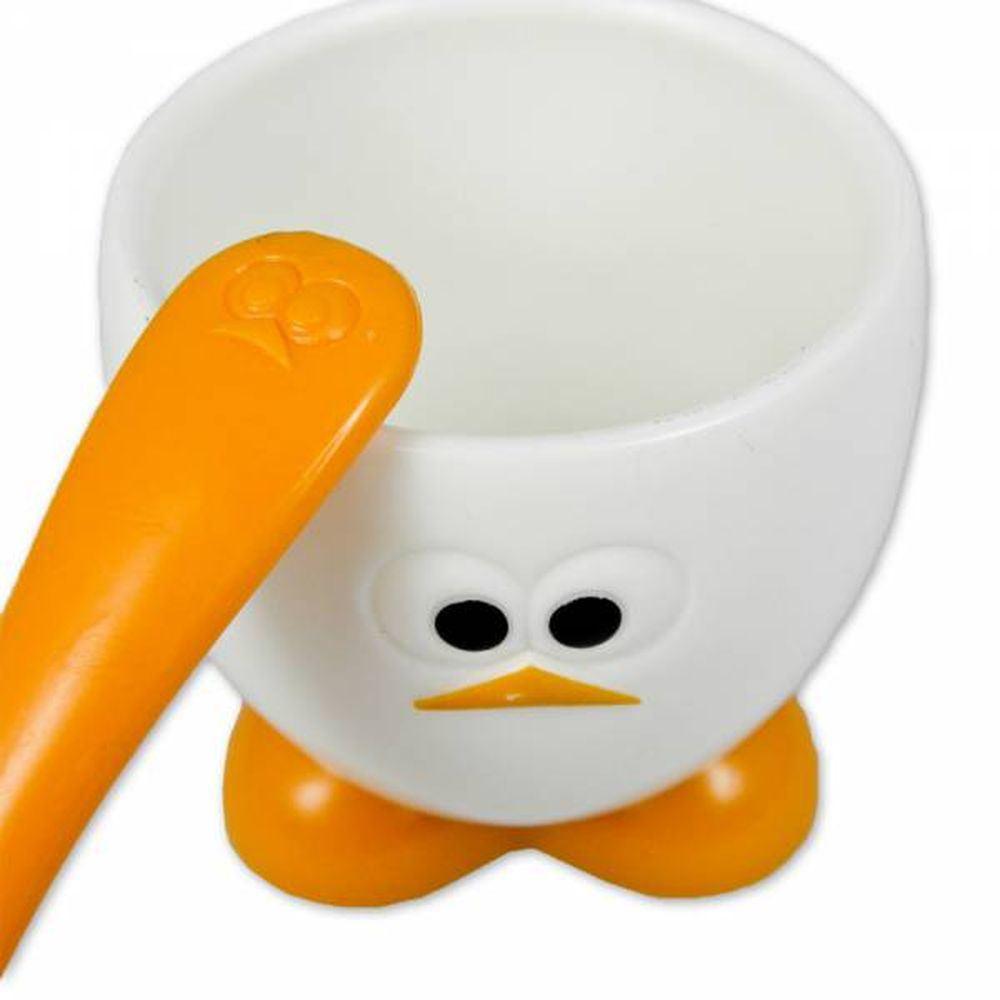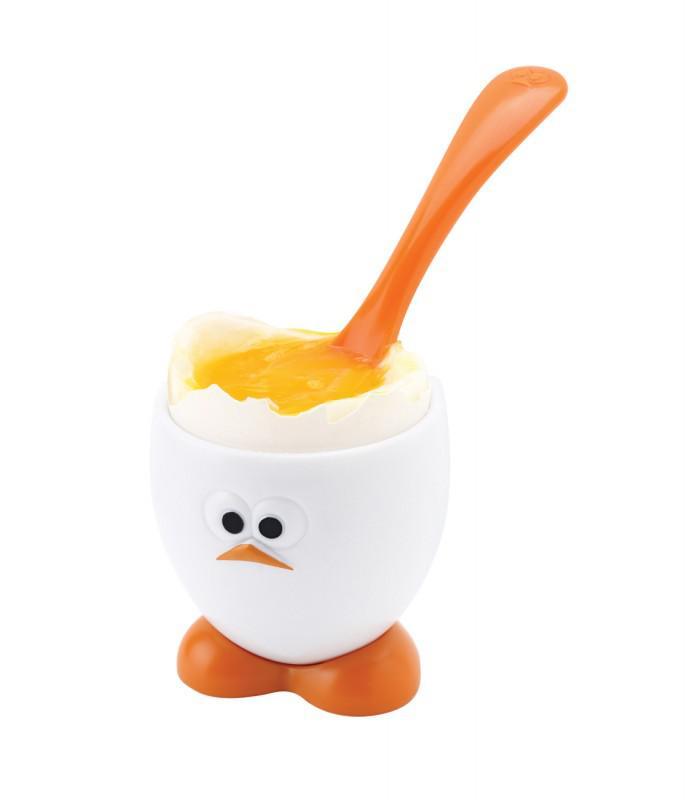The first image is the image on the left, the second image is the image on the right. Analyze the images presented: Is the assertion "One image shows a spoon inserted in yolk in the egg-shaped cup with orange feet." valid? Answer yes or no. Yes. 